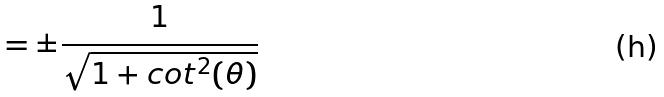Convert formula to latex. <formula><loc_0><loc_0><loc_500><loc_500>= \pm \frac { 1 } { \sqrt { 1 + c o t ^ { 2 } ( \theta ) } }</formula> 